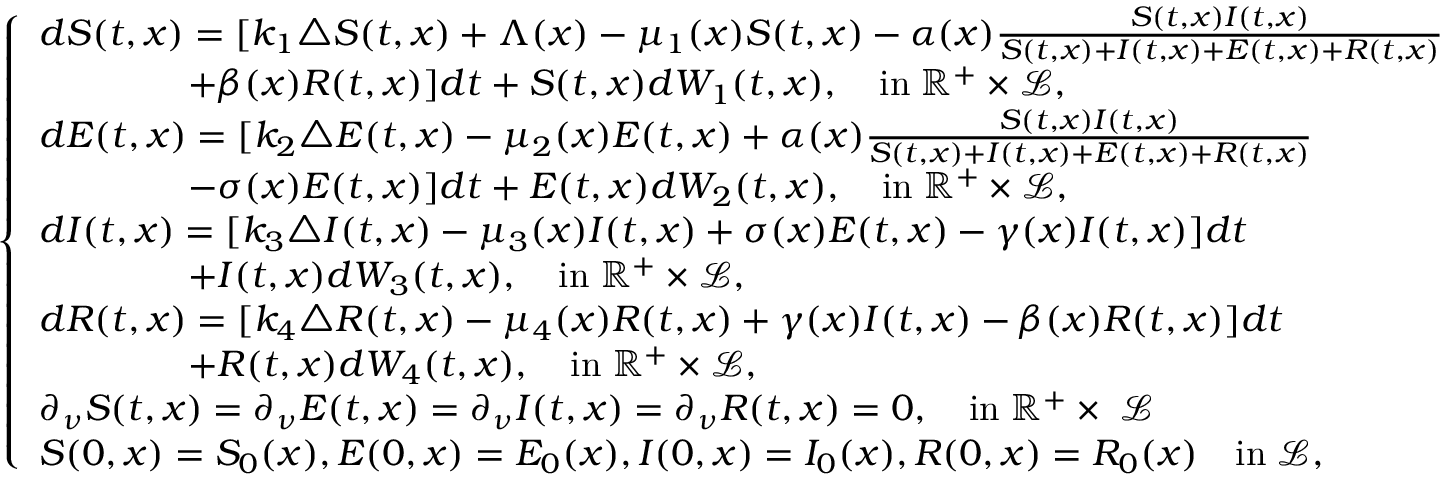Convert formula to latex. <formula><loc_0><loc_0><loc_500><loc_500>\left \{ \begin{array} { l l } { d S ( t , x ) = [ k _ { 1 } \triangle S ( t , x ) + \Lambda ( x ) - \mu _ { 1 } ( x ) S ( t , x ) - \alpha ( x ) \frac { S ( t , x ) I ( t , x ) } { S ( t , x ) + I ( t , x ) + E ( t , x ) + R ( t , x ) } } \\ { \quad + \beta ( x ) R ( t , x ) ] d t + S ( t , x ) d W _ { 1 } ( t , x ) , \quad i n \, \mathbb { R ^ { + } } \times \mathcal { L } , } \\ { d E ( t , x ) = [ k _ { 2 } \triangle E ( t , x ) - \mu _ { 2 } ( x ) E ( t , x ) + \alpha ( x ) \frac { S ( t , x ) I ( t , x ) } { S ( t , x ) + I ( t , x ) + E ( t , x ) + R ( t , x ) } } \\ { \quad - \sigma ( x ) E ( t , x ) ] d t + E ( t , x ) d W _ { 2 } ( t , x ) , \quad i n \, \mathbb { R ^ { + } } \times \mathcal { L } , } \\ { d I ( t , x ) = [ k _ { 3 } \triangle I ( t , x ) - \mu _ { 3 } ( x ) I ( t , x ) + \sigma ( x ) E ( t , x ) - \gamma ( x ) I ( t , x ) ] d t } \\ { \quad + I ( t , x ) d W _ { 3 } ( t , x ) , \quad i n \, \mathbb { R ^ { + } } \times \mathcal { L } , } \\ { d R ( t , x ) = [ k _ { 4 } \triangle R ( t , x ) - \mu _ { 4 } ( x ) R ( t , x ) + \gamma ( x ) I ( t , x ) - \beta ( x ) R ( t , x ) ] d t } \\ { \quad + R ( t , x ) d W _ { 4 } ( t , x ) , \quad i n \, \mathbb { R ^ { + } } \times \mathcal { L } , } \\ { \partial _ { \nu } S ( t , x ) = \partial _ { \nu } E ( t , x ) = \partial _ { \nu } I ( t , x ) = \partial _ { \nu } R ( t , x ) = 0 , \quad i n \, \mathbb { R ^ { + } } \times \partial \mathcal { L } } \\ { S ( 0 , x ) = S _ { 0 } ( x ) , E ( 0 , x ) = E _ { 0 } ( x ) , I ( 0 , x ) = I _ { 0 } ( x ) , R ( 0 , x ) = R _ { 0 } ( x ) \quad i n \, \mathcal { L } , } \end{array}</formula> 